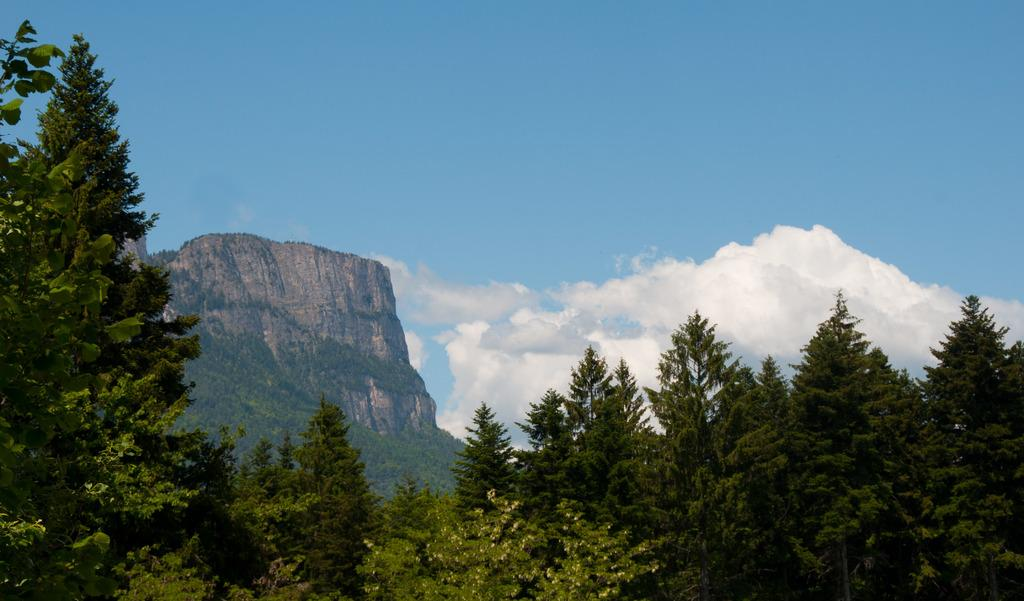What type of landform is present in the image? There is a hill in the image. What can be seen growing on the hill? There are many trees in the image. What is visible in the background of the image? The sky is visible in the background of the image. What is the condition of the sky in the image? There are clouds in the sky. Can you see a bat flying near the trees in the image? There is no bat visible in the image; it only features a hill with many trees and a sky with clouds. What flavor of cake is being served on the hill in the image? There is no cake present in the image; it only features a hill with many trees and a sky with clouds. 